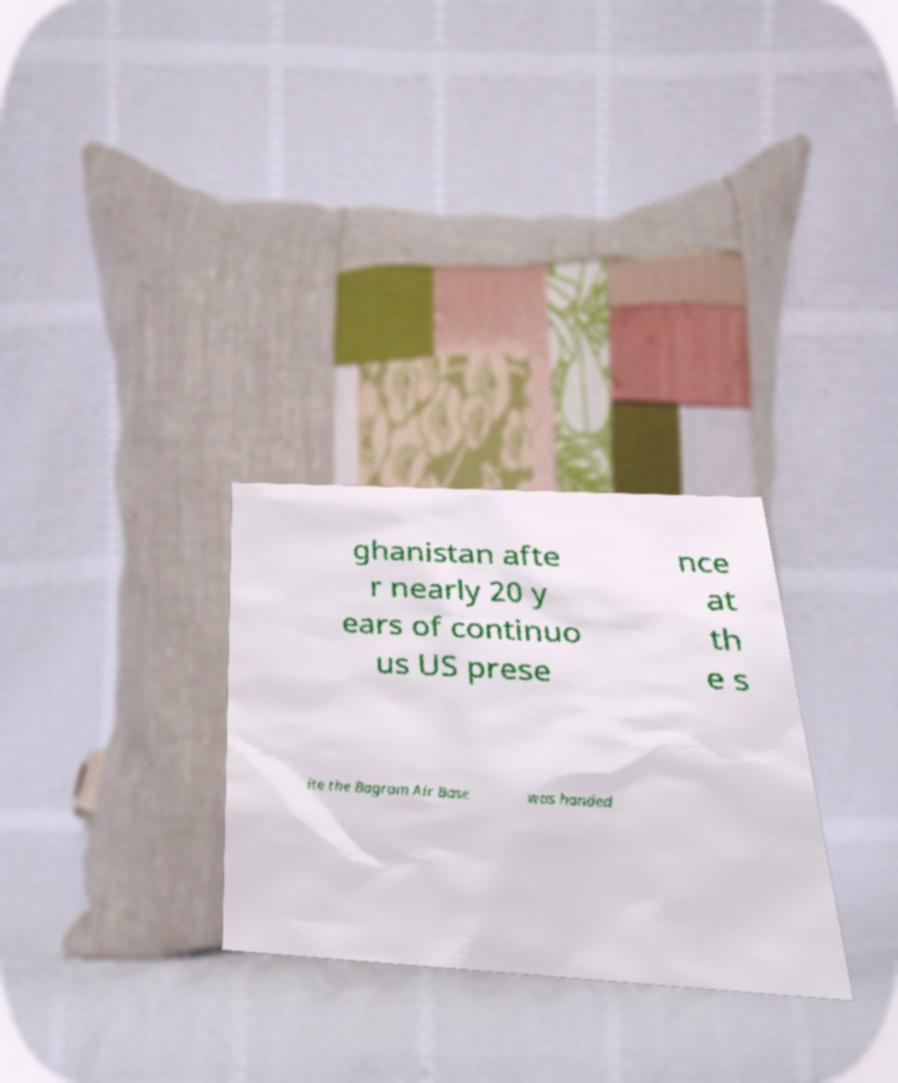What messages or text are displayed in this image? I need them in a readable, typed format. ghanistan afte r nearly 20 y ears of continuo us US prese nce at th e s ite the Bagram Air Base was handed 